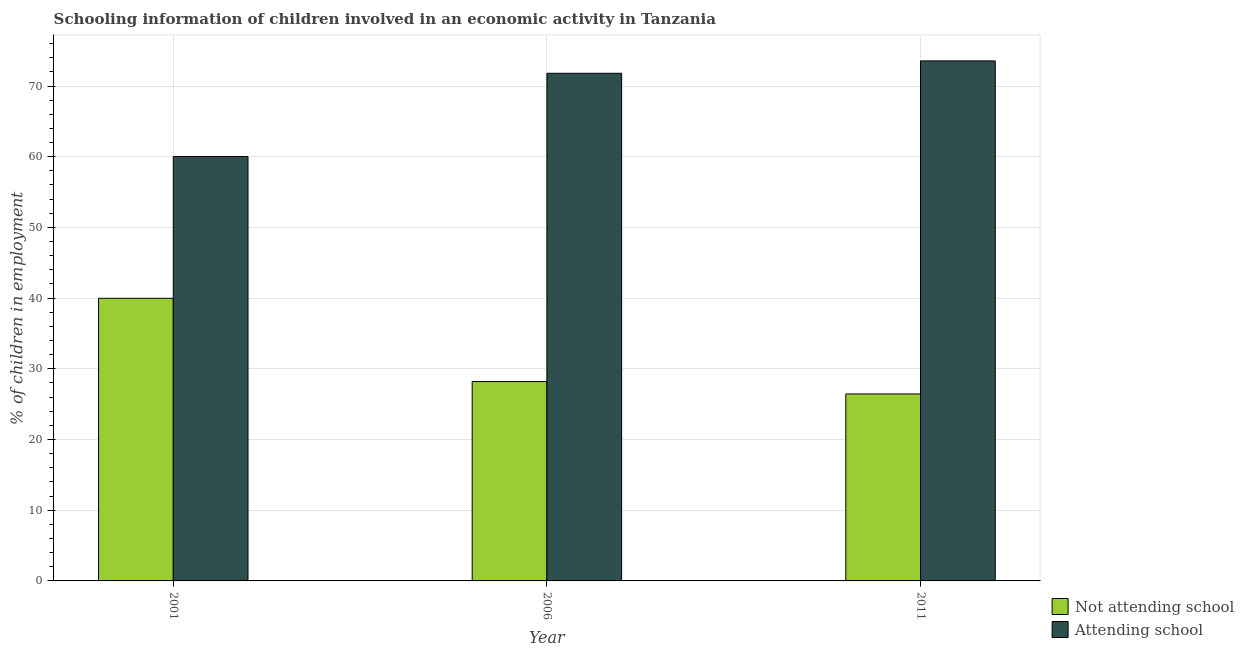How many different coloured bars are there?
Offer a terse response. 2. How many groups of bars are there?
Ensure brevity in your answer.  3. Are the number of bars per tick equal to the number of legend labels?
Offer a terse response. Yes. How many bars are there on the 2nd tick from the right?
Keep it short and to the point. 2. What is the label of the 1st group of bars from the left?
Provide a succinct answer. 2001. In how many cases, is the number of bars for a given year not equal to the number of legend labels?
Your answer should be compact. 0. What is the percentage of employed children who are not attending school in 2006?
Your answer should be compact. 28.2. Across all years, what is the maximum percentage of employed children who are attending school?
Your answer should be compact. 73.55. Across all years, what is the minimum percentage of employed children who are attending school?
Offer a terse response. 60.02. In which year was the percentage of employed children who are attending school maximum?
Give a very brief answer. 2011. In which year was the percentage of employed children who are not attending school minimum?
Provide a succinct answer. 2011. What is the total percentage of employed children who are not attending school in the graph?
Give a very brief answer. 94.62. What is the difference between the percentage of employed children who are not attending school in 2001 and that in 2006?
Keep it short and to the point. 11.78. What is the difference between the percentage of employed children who are not attending school in 2001 and the percentage of employed children who are attending school in 2006?
Make the answer very short. 11.78. What is the average percentage of employed children who are attending school per year?
Offer a terse response. 68.46. In the year 2001, what is the difference between the percentage of employed children who are not attending school and percentage of employed children who are attending school?
Ensure brevity in your answer.  0. What is the ratio of the percentage of employed children who are not attending school in 2001 to that in 2006?
Provide a short and direct response. 1.42. Is the percentage of employed children who are attending school in 2006 less than that in 2011?
Give a very brief answer. Yes. What is the difference between the highest and the second highest percentage of employed children who are not attending school?
Provide a short and direct response. 11.78. What is the difference between the highest and the lowest percentage of employed children who are not attending school?
Give a very brief answer. 13.53. In how many years, is the percentage of employed children who are not attending school greater than the average percentage of employed children who are not attending school taken over all years?
Keep it short and to the point. 1. Is the sum of the percentage of employed children who are attending school in 2001 and 2006 greater than the maximum percentage of employed children who are not attending school across all years?
Provide a succinct answer. Yes. What does the 1st bar from the left in 2001 represents?
Ensure brevity in your answer.  Not attending school. What does the 1st bar from the right in 2006 represents?
Give a very brief answer. Attending school. Are all the bars in the graph horizontal?
Keep it short and to the point. No. How many years are there in the graph?
Keep it short and to the point. 3. Does the graph contain grids?
Ensure brevity in your answer.  Yes. How are the legend labels stacked?
Keep it short and to the point. Vertical. What is the title of the graph?
Ensure brevity in your answer.  Schooling information of children involved in an economic activity in Tanzania. What is the label or title of the X-axis?
Your answer should be compact. Year. What is the label or title of the Y-axis?
Offer a terse response. % of children in employment. What is the % of children in employment of Not attending school in 2001?
Offer a very short reply. 39.98. What is the % of children in employment of Attending school in 2001?
Offer a terse response. 60.02. What is the % of children in employment in Not attending school in 2006?
Provide a short and direct response. 28.2. What is the % of children in employment in Attending school in 2006?
Your answer should be very brief. 71.8. What is the % of children in employment in Not attending school in 2011?
Give a very brief answer. 26.45. What is the % of children in employment of Attending school in 2011?
Offer a very short reply. 73.55. Across all years, what is the maximum % of children in employment of Not attending school?
Give a very brief answer. 39.98. Across all years, what is the maximum % of children in employment in Attending school?
Provide a succinct answer. 73.55. Across all years, what is the minimum % of children in employment of Not attending school?
Your answer should be compact. 26.45. Across all years, what is the minimum % of children in employment in Attending school?
Provide a succinct answer. 60.02. What is the total % of children in employment in Not attending school in the graph?
Your response must be concise. 94.62. What is the total % of children in employment of Attending school in the graph?
Keep it short and to the point. 205.38. What is the difference between the % of children in employment of Not attending school in 2001 and that in 2006?
Provide a short and direct response. 11.78. What is the difference between the % of children in employment of Attending school in 2001 and that in 2006?
Your response must be concise. -11.78. What is the difference between the % of children in employment of Not attending school in 2001 and that in 2011?
Provide a succinct answer. 13.53. What is the difference between the % of children in employment of Attending school in 2001 and that in 2011?
Your answer should be compact. -13.53. What is the difference between the % of children in employment of Not attending school in 2006 and that in 2011?
Provide a short and direct response. 1.75. What is the difference between the % of children in employment of Attending school in 2006 and that in 2011?
Offer a terse response. -1.75. What is the difference between the % of children in employment of Not attending school in 2001 and the % of children in employment of Attending school in 2006?
Make the answer very short. -31.82. What is the difference between the % of children in employment of Not attending school in 2001 and the % of children in employment of Attending school in 2011?
Your answer should be compact. -33.58. What is the difference between the % of children in employment of Not attending school in 2006 and the % of children in employment of Attending school in 2011?
Make the answer very short. -45.35. What is the average % of children in employment in Not attending school per year?
Your answer should be very brief. 31.54. What is the average % of children in employment in Attending school per year?
Make the answer very short. 68.46. In the year 2001, what is the difference between the % of children in employment of Not attending school and % of children in employment of Attending school?
Your response must be concise. -20.05. In the year 2006, what is the difference between the % of children in employment in Not attending school and % of children in employment in Attending school?
Provide a succinct answer. -43.6. In the year 2011, what is the difference between the % of children in employment of Not attending school and % of children in employment of Attending school?
Offer a very short reply. -47.11. What is the ratio of the % of children in employment of Not attending school in 2001 to that in 2006?
Your answer should be compact. 1.42. What is the ratio of the % of children in employment of Attending school in 2001 to that in 2006?
Make the answer very short. 0.84. What is the ratio of the % of children in employment in Not attending school in 2001 to that in 2011?
Provide a succinct answer. 1.51. What is the ratio of the % of children in employment in Attending school in 2001 to that in 2011?
Give a very brief answer. 0.82. What is the ratio of the % of children in employment in Not attending school in 2006 to that in 2011?
Provide a succinct answer. 1.07. What is the ratio of the % of children in employment in Attending school in 2006 to that in 2011?
Your response must be concise. 0.98. What is the difference between the highest and the second highest % of children in employment in Not attending school?
Offer a very short reply. 11.78. What is the difference between the highest and the second highest % of children in employment in Attending school?
Keep it short and to the point. 1.75. What is the difference between the highest and the lowest % of children in employment in Not attending school?
Your answer should be very brief. 13.53. What is the difference between the highest and the lowest % of children in employment of Attending school?
Keep it short and to the point. 13.53. 